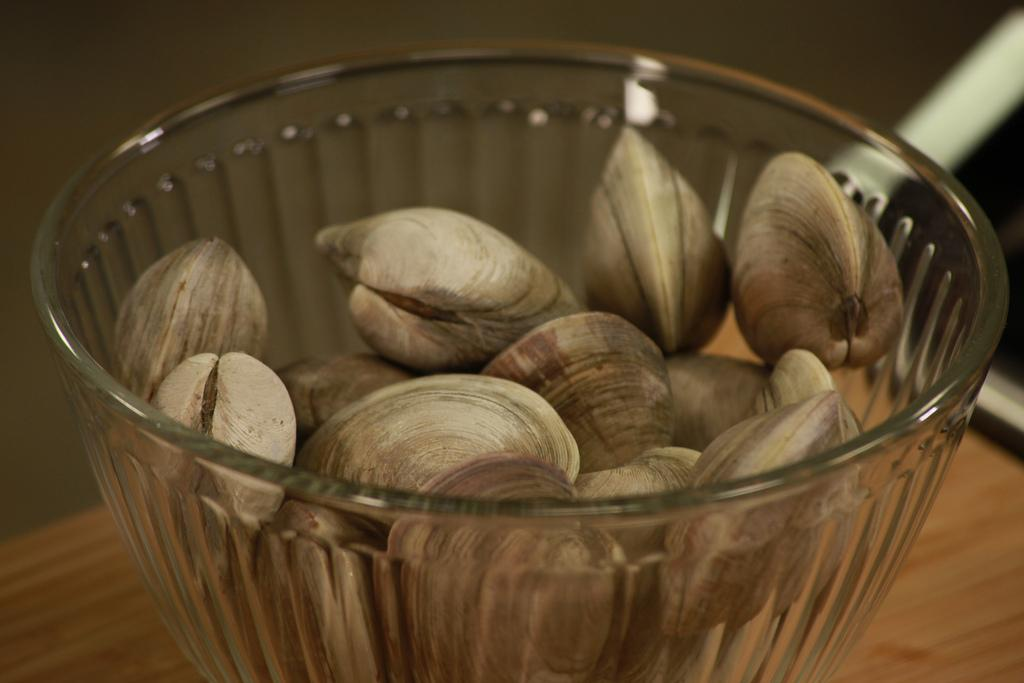What is in the bowl that is visible in the image? There are shells in a bowl in the image. Where is the bowl located? The bowl is placed on a wooden surface. Can you describe anything in the background of the image? There is an object in the background of the image, but its details are not clear. What type of food is the minister eating in the image? There is no minister or food present in the image; it features a bowl of shells on a wooden surface with an object in the background. 